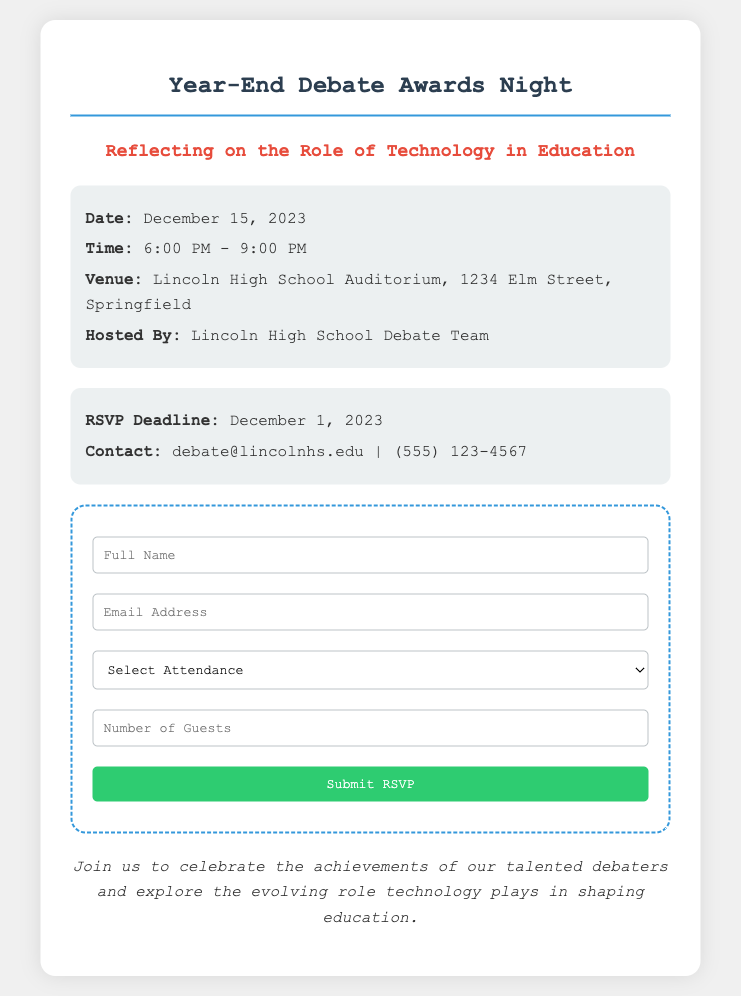What is the date of the event? The date of the event is explicitly stated in the document as December 15, 2023.
Answer: December 15, 2023 What time does the event start? The starting time of the event is mentioned in the document as 6:00 PM.
Answer: 6:00 PM Where is the event taking place? The location of the event is provided in the document, which is Lincoln High School Auditorium, 1234 Elm Street, Springfield.
Answer: Lincoln High School Auditorium, 1234 Elm Street, Springfield Who is hosting the event? The document specifies that Lincoln High School Debate Team is hosting the event.
Answer: Lincoln High School Debate Team What is the RSVP deadline? The RSVP deadline is mentioned in the document as December 1, 2023.
Answer: December 1, 2023 How many guests can you RSVP for? The RSVP form allows for a maximum of 2 guests, as indicated in the document.
Answer: 2 What type of event is this? The document describes the event as a Year-End Debate Awards Night.
Answer: Year-End Debate Awards Night What is the significance of the event's theme? The theme reflects on the role of technology in education, indicating a focus on discussing advancements in this area.
Answer: Reflecting on the Role of Technology in Education 